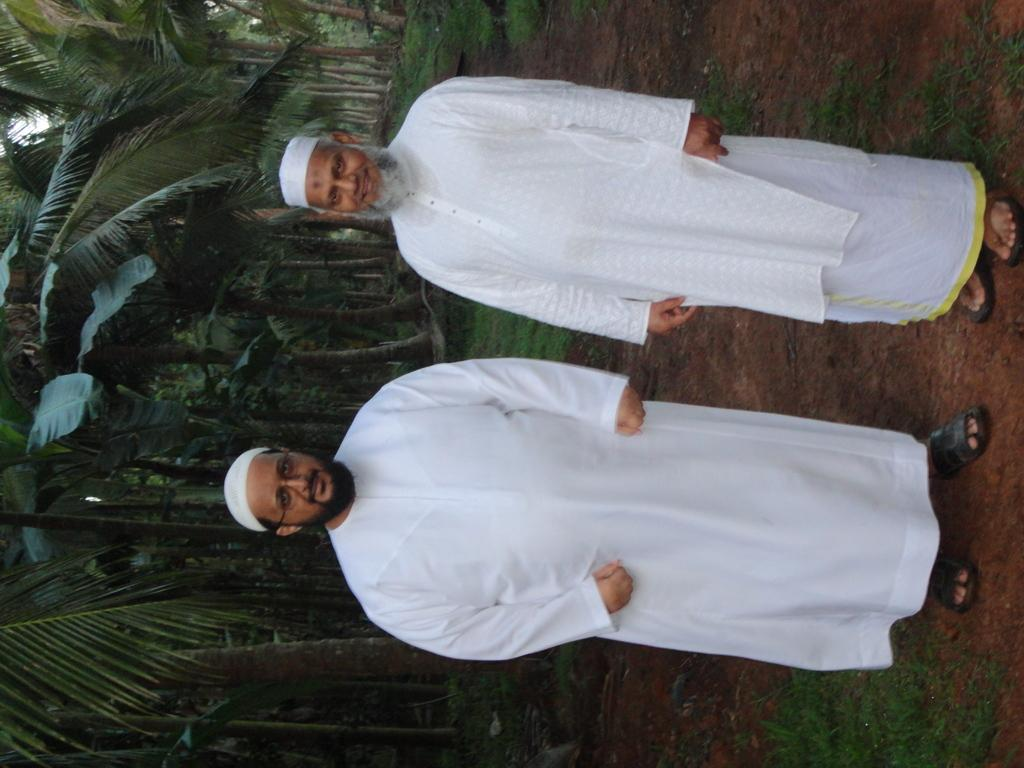How many people are in the image? There are two persons standing in the image. What is the surface they are standing on? The persons are standing on the ground. What type of vegetation can be seen in the image? Grass and trees are visible in the image. Can you determine the time of day the image was taken? The image was likely taken during the day, as there is sufficient light to see the details. What advice is the person on the left giving to the person on the right in the image? There is no indication in the image that any advice is being given, as there is no visible interaction between the two persons. 